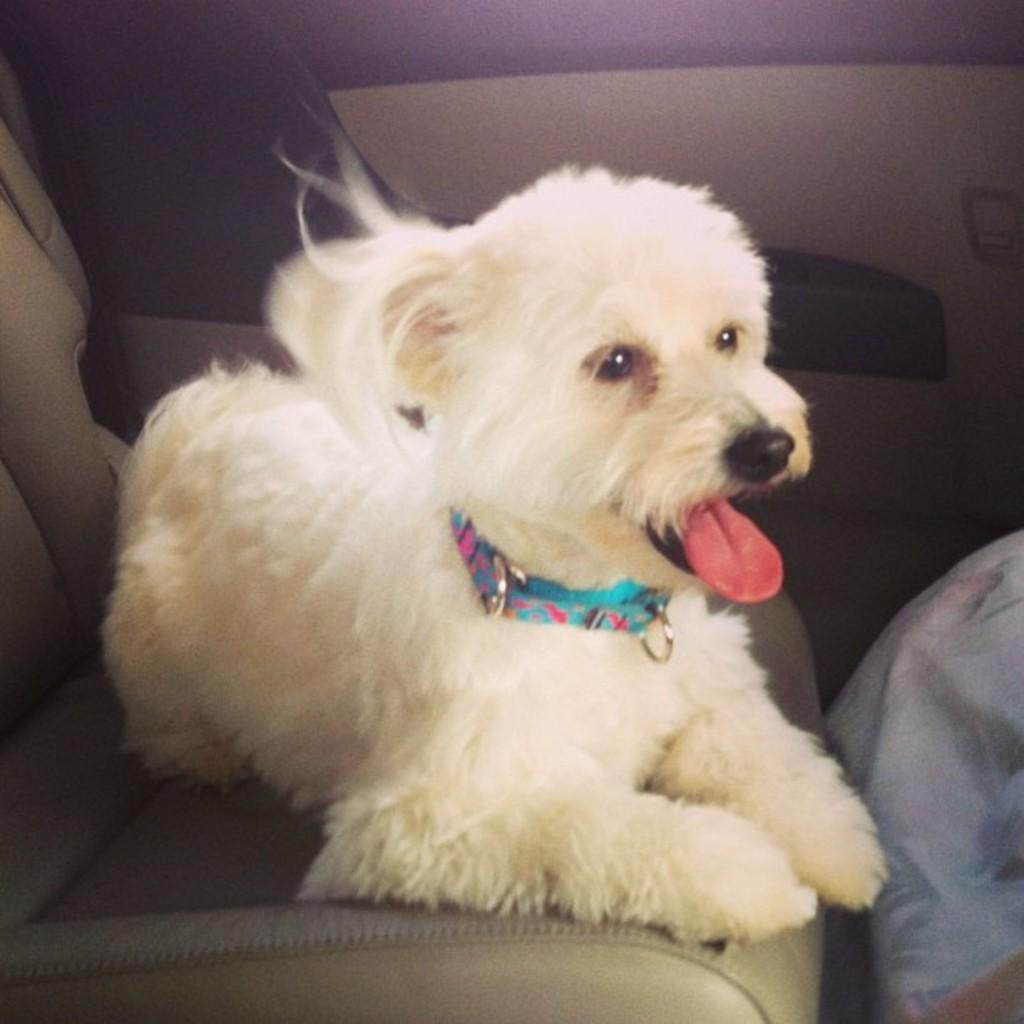What is the setting of the image? The image is taken inside a vehicle. What type of animal is present in the image? There is a dog in the image. Where is the dog located in the vehicle? The dog is sitting on a seat. What is the color of the dog? The dog is white in color. What is the dog wearing in the image? The dog is wearing a belt. How does the dog show respect to the driver in the image? The image does not show the dog displaying respect to the driver, as it only depicts the dog sitting on a seat and wearing a belt. 